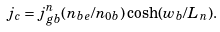<formula> <loc_0><loc_0><loc_500><loc_500>j _ { c } = j _ { g b } ^ { n } ( n _ { b e } / n _ { 0 b } ) \cosh ( w _ { b } / L _ { n } ) .</formula> 